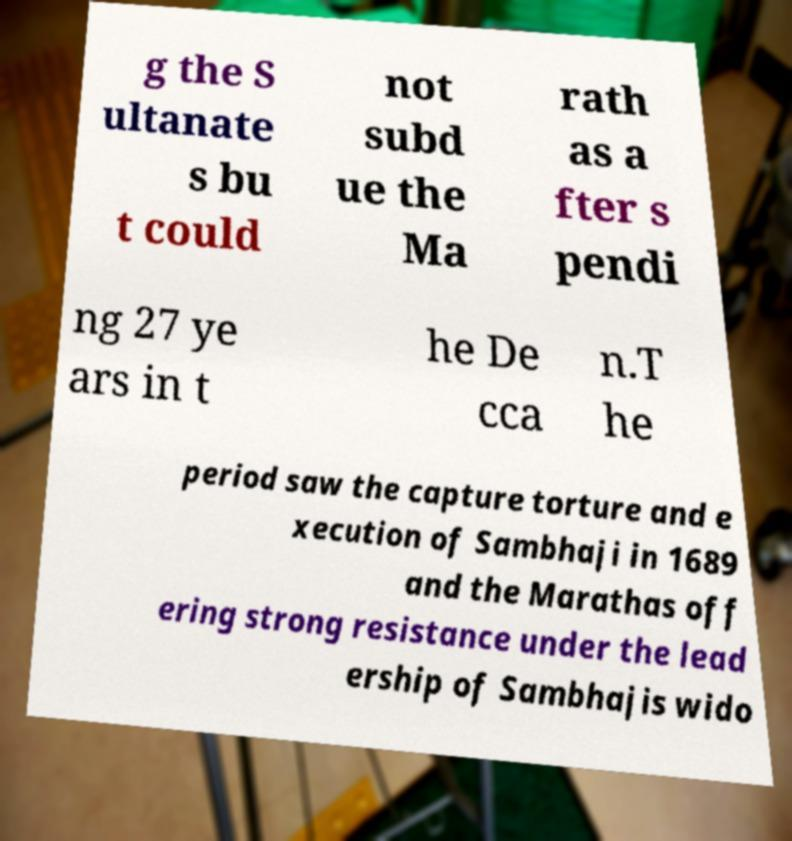Could you assist in decoding the text presented in this image and type it out clearly? g the S ultanate s bu t could not subd ue the Ma rath as a fter s pendi ng 27 ye ars in t he De cca n.T he period saw the capture torture and e xecution of Sambhaji in 1689 and the Marathas off ering strong resistance under the lead ership of Sambhajis wido 